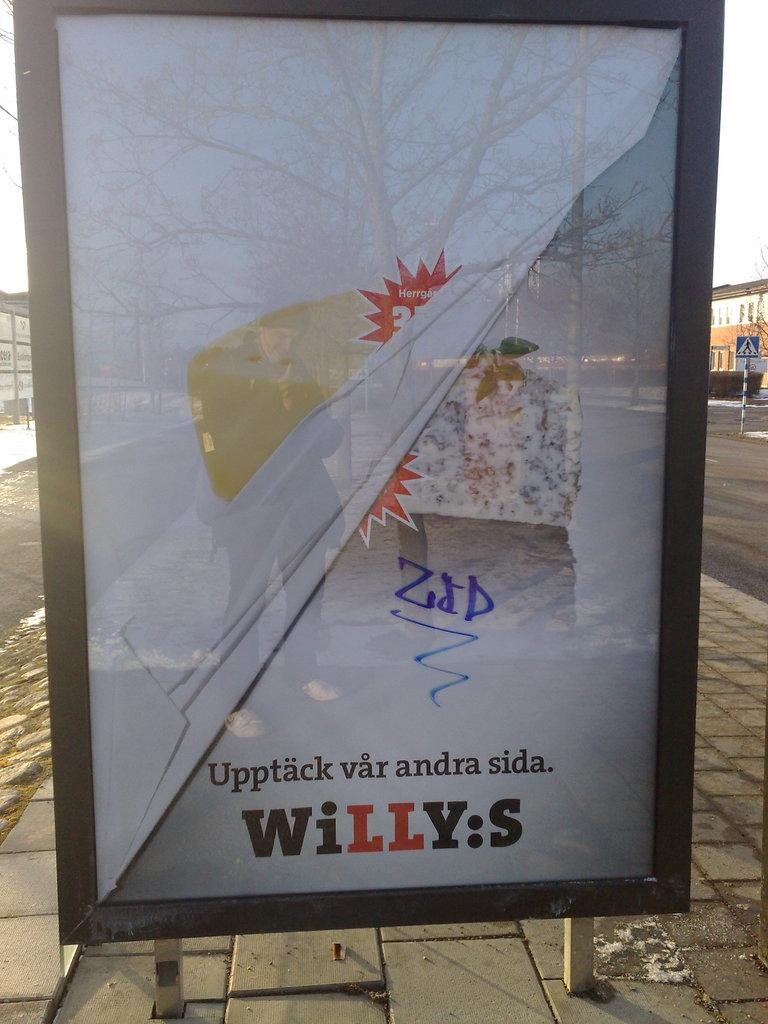<image>
Create a compact narrative representing the image presented. A bus stop sign for Willy's has a bit of graffiti on it. 